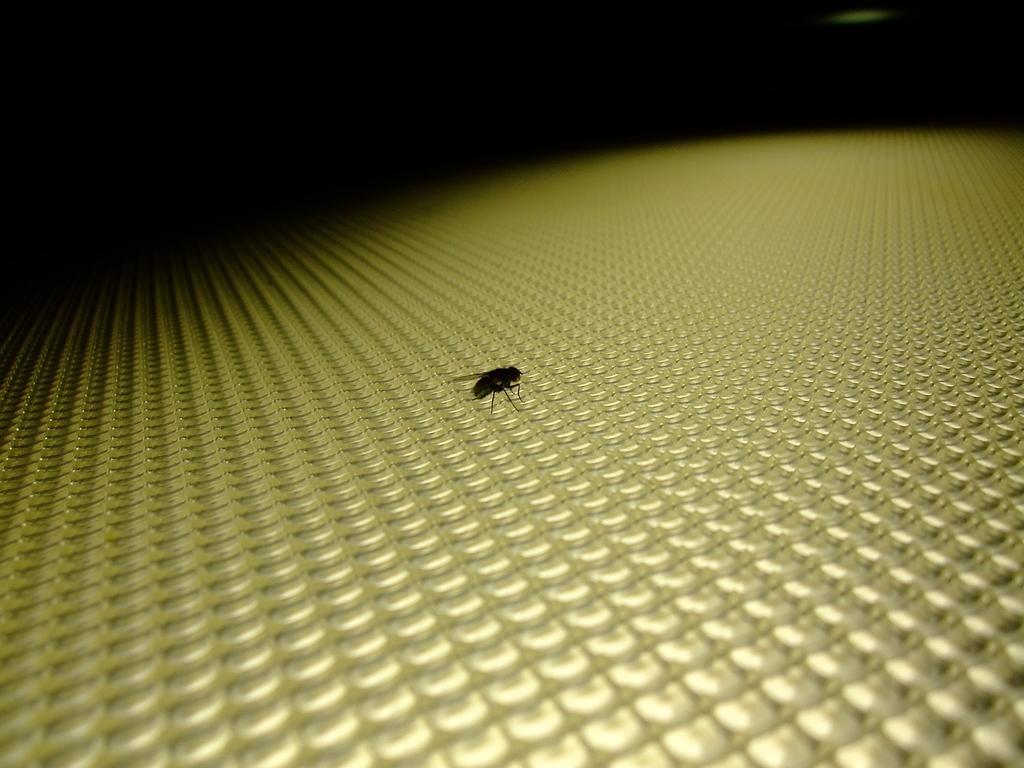Could you give a brief overview of what you see in this image? In this image we can see an insect on the yellow color surface and a dark background. 